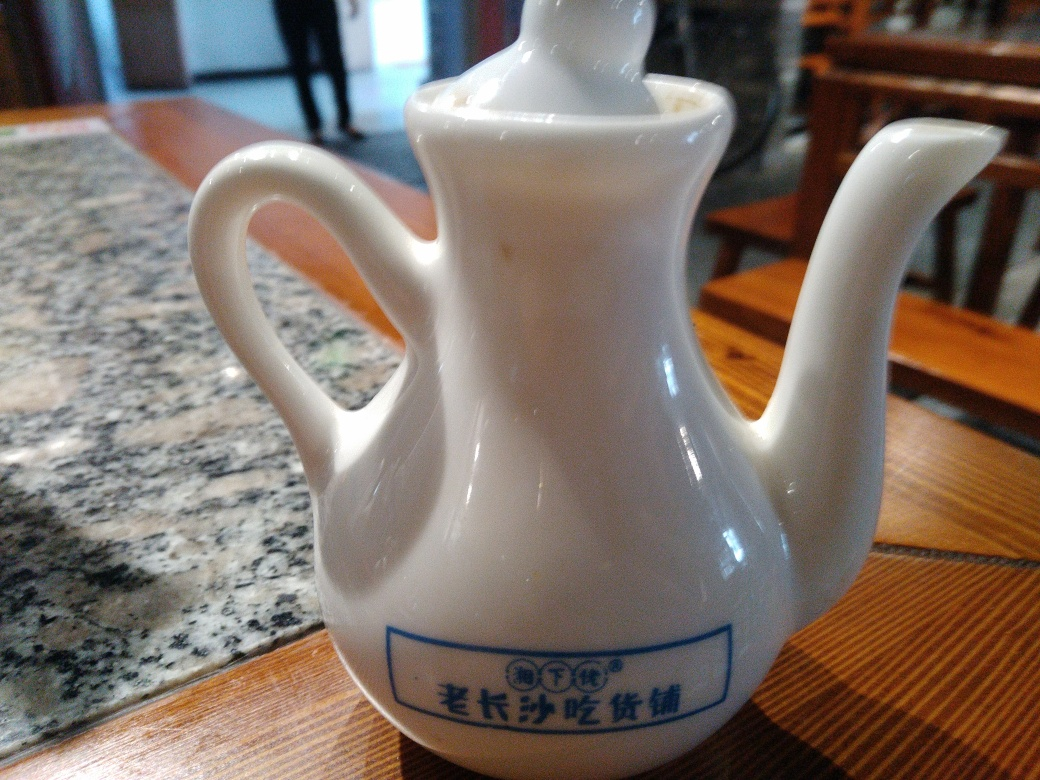Is the content complete? A. Yes B. No Answer with the option's letter from the given choices directly. Based on the provided image, the content appears complete. The image shows a white porcelain teapot with a distinctive design. The clarity and detail in the photograph are sufficient to convey the object's appearance and context, indicating a complete representation. 